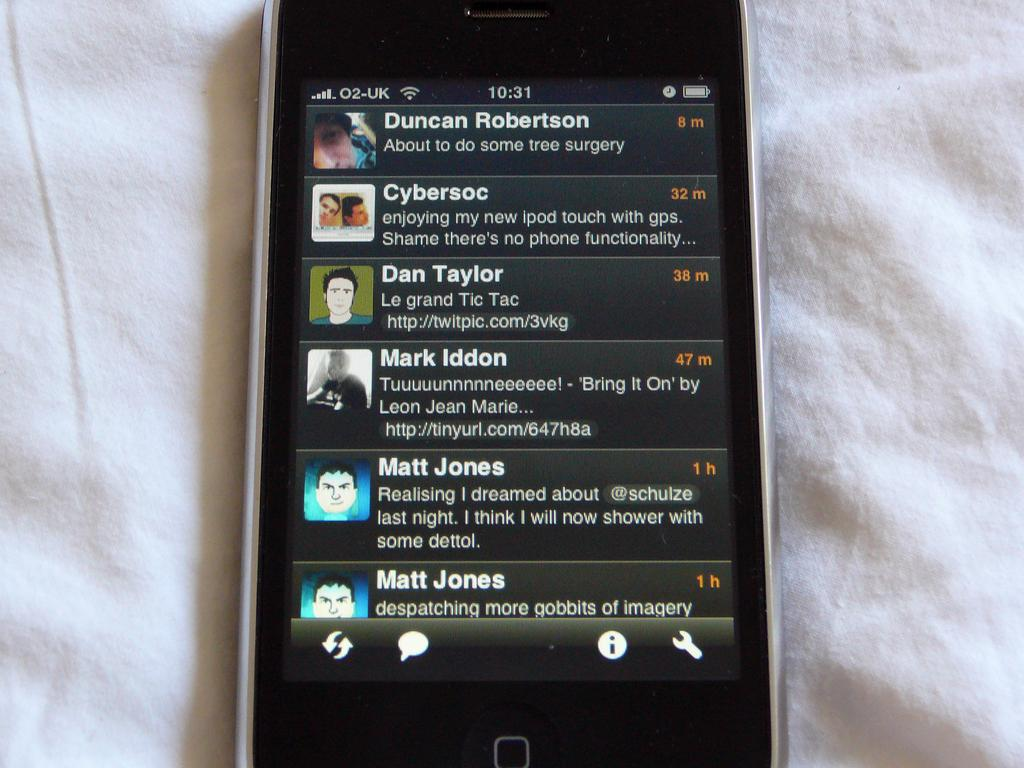What object is the main focus of the image? There is a mobile in the image. What is the mobile placed on? The mobile is placed on a white cloth. What can be seen on the mobile's screen? The mobile's screen displays text, images of people, symbols, and numbers. What color are the eyes of the toy in the image? There is no toy present in the image, and therefore no eyes to describe. 